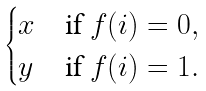Convert formula to latex. <formula><loc_0><loc_0><loc_500><loc_500>\begin{cases} x & \text {if } f ( i ) = 0 , \\ y & \text {if } f ( i ) = 1 . \end{cases}</formula> 